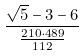Convert formula to latex. <formula><loc_0><loc_0><loc_500><loc_500>\frac { \sqrt { 5 } - 3 - 6 } { \frac { 2 1 0 \cdot 4 8 9 } { 1 1 2 } }</formula> 